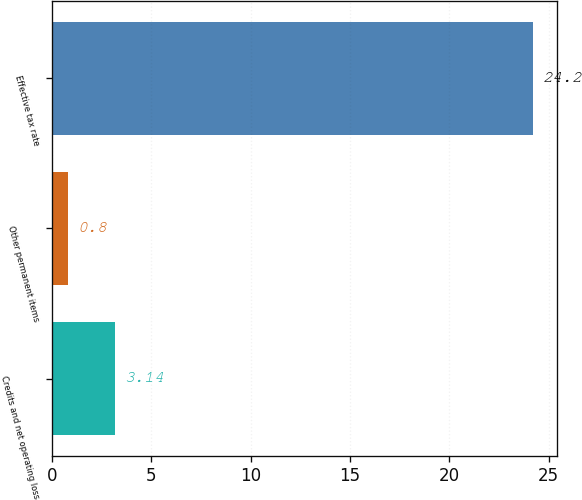Convert chart to OTSL. <chart><loc_0><loc_0><loc_500><loc_500><bar_chart><fcel>Credits and net operating loss<fcel>Other permanent items<fcel>Effective tax rate<nl><fcel>3.14<fcel>0.8<fcel>24.2<nl></chart> 